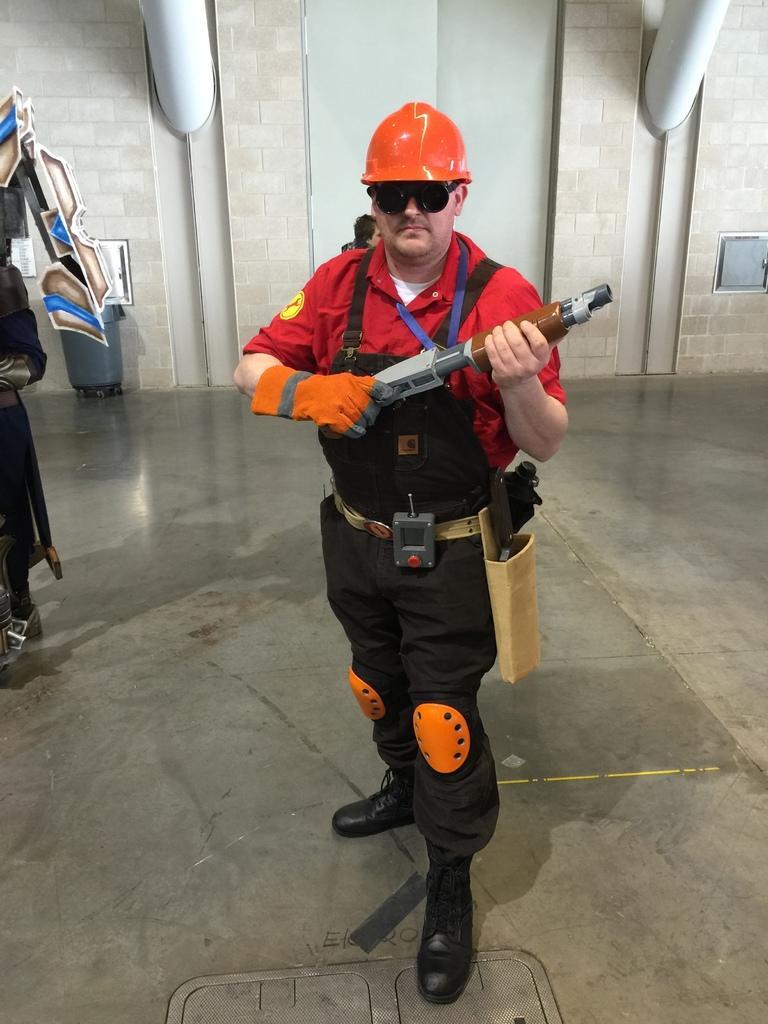Please provide a concise description of this image. In this image I see a man who is holding a toy gun in his hands and I see that he is wearing a helmet which is of orange in color and I can also see that he is wearing black color shades and I see the floor. In the background I see the wall and I see a person's head over here. 